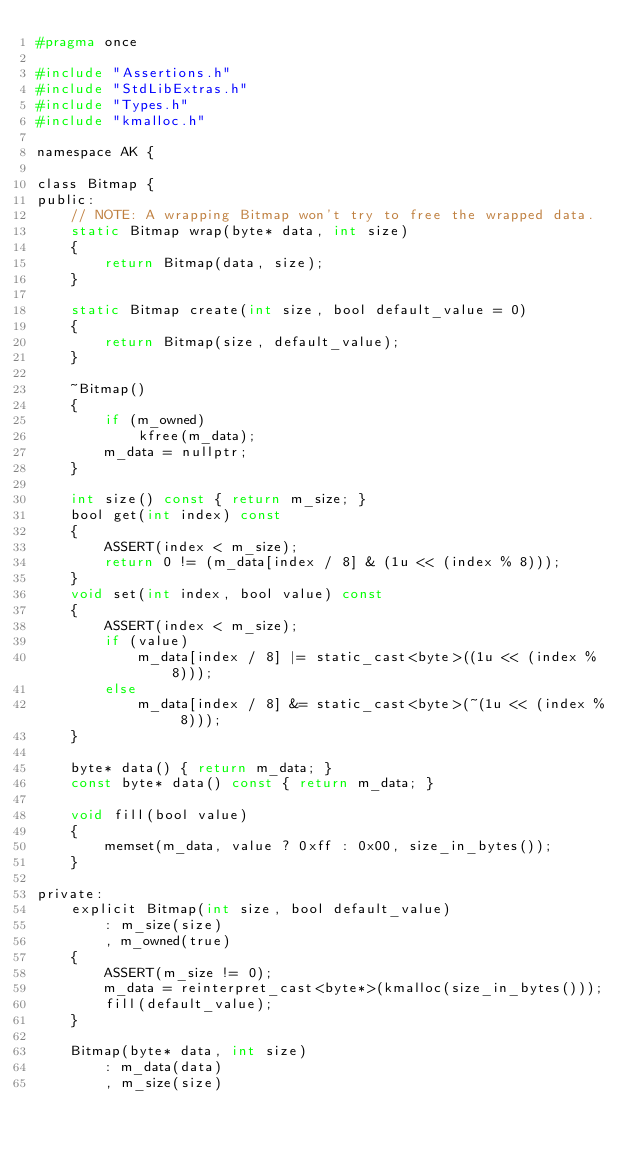Convert code to text. <code><loc_0><loc_0><loc_500><loc_500><_C_>#pragma once

#include "Assertions.h"
#include "StdLibExtras.h"
#include "Types.h"
#include "kmalloc.h"

namespace AK {

class Bitmap {
public:
    // NOTE: A wrapping Bitmap won't try to free the wrapped data.
    static Bitmap wrap(byte* data, int size)
    {
        return Bitmap(data, size);
    }

    static Bitmap create(int size, bool default_value = 0)
    {
        return Bitmap(size, default_value);
    }

    ~Bitmap()
    {
        if (m_owned)
            kfree(m_data);
        m_data = nullptr;
    }

    int size() const { return m_size; }
    bool get(int index) const
    {
        ASSERT(index < m_size);
        return 0 != (m_data[index / 8] & (1u << (index % 8)));
    }
    void set(int index, bool value) const
    {
        ASSERT(index < m_size);
        if (value)
            m_data[index / 8] |= static_cast<byte>((1u << (index % 8)));
        else
            m_data[index / 8] &= static_cast<byte>(~(1u << (index % 8)));
    }

    byte* data() { return m_data; }
    const byte* data() const { return m_data; }

    void fill(bool value)
    {
        memset(m_data, value ? 0xff : 0x00, size_in_bytes());
    }

private:
    explicit Bitmap(int size, bool default_value)
        : m_size(size)
        , m_owned(true)
    {
        ASSERT(m_size != 0);
        m_data = reinterpret_cast<byte*>(kmalloc(size_in_bytes()));
        fill(default_value);
    }

    Bitmap(byte* data, int size)
        : m_data(data)
        , m_size(size)</code> 